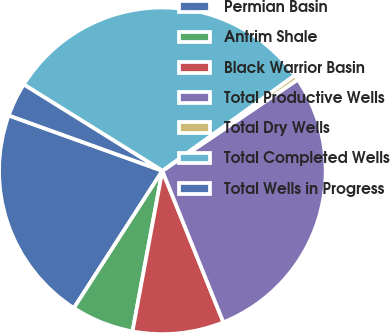Convert chart to OTSL. <chart><loc_0><loc_0><loc_500><loc_500><pie_chart><fcel>Permian Basin<fcel>Antrim Shale<fcel>Black Warrior Basin<fcel>Total Productive Wells<fcel>Total Dry Wells<fcel>Total Completed Wells<fcel>Total Wells in Progress<nl><fcel>21.39%<fcel>6.19%<fcel>9.02%<fcel>28.34%<fcel>0.52%<fcel>31.18%<fcel>3.36%<nl></chart> 